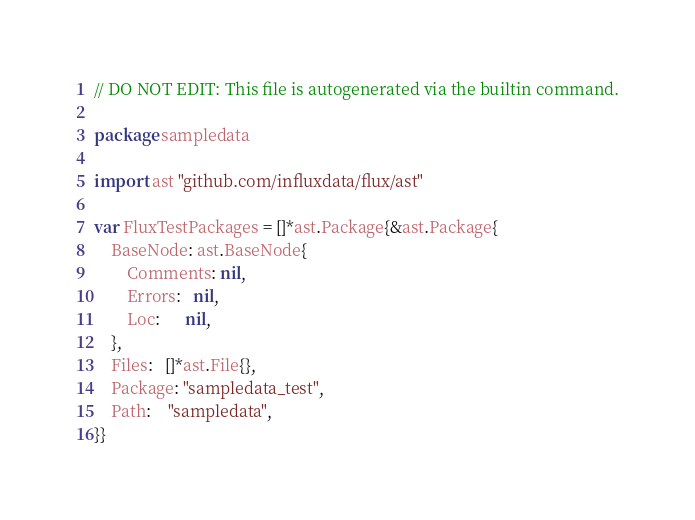Convert code to text. <code><loc_0><loc_0><loc_500><loc_500><_Go_>// DO NOT EDIT: This file is autogenerated via the builtin command.

package sampledata

import ast "github.com/influxdata/flux/ast"

var FluxTestPackages = []*ast.Package{&ast.Package{
	BaseNode: ast.BaseNode{
		Comments: nil,
		Errors:   nil,
		Loc:      nil,
	},
	Files:   []*ast.File{},
	Package: "sampledata_test",
	Path:    "sampledata",
}}
</code> 